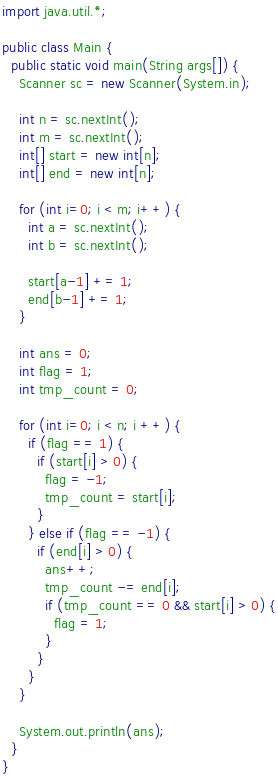Convert code to text. <code><loc_0><loc_0><loc_500><loc_500><_Java_>import java.util.*;

public class Main {
  public static void main(String args[]) {
    Scanner sc = new Scanner(System.in);

    int n = sc.nextInt();
    int m = sc.nextInt();
    int[] start = new int[n];
    int[] end = new int[n];

    for (int i=0; i < m; i++) {
      int a = sc.nextInt();
      int b = sc.nextInt();

      start[a-1] += 1;
      end[b-1] += 1;
    }

    int ans = 0;
    int flag = 1;
    int tmp_count = 0;

    for (int i=0; i < n; i ++) {
      if (flag == 1) {
        if (start[i] > 0) {
          flag = -1;
          tmp_count = start[i];
        }
      } else if (flag == -1) {
        if (end[i] > 0) {
          ans++;
          tmp_count -= end[i];
          if (tmp_count == 0 && start[i] > 0) {
            flag = 1;
          }
        }
      }
    }

    System.out.println(ans);
  }
}
</code> 